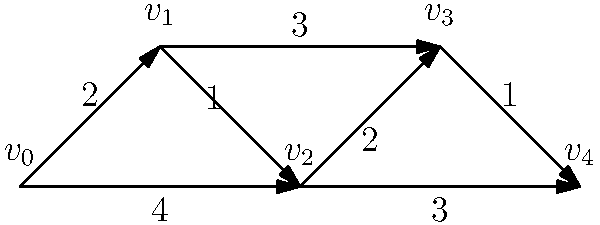A small telecommunication company is expanding its network infrastructure. The graph represents their current network topology, where vertices are data centers and edges are communication links with associated costs. Using Dijkstra's algorithm, what is the shortest path from $v_0$ to $v_4$, and what is its total cost? Let's apply Dijkstra's algorithm step by step:

1) Initialize:
   - Set distance to $v_0$ as 0 and all others as infinity.
   - Set all nodes as unvisited.
   - Set $v_0$ as the current node.

2) For the current node, consider all unvisited neighbors and calculate their tentative distances:
   - $v_1$: 0 + 2 = 2
   - $v_2$: 0 + 4 = 4

3) Mark $v_0$ as visited. Set $v_1$ (lowest tentative distance) as the new current node.

4) From $v_1$:
   - $v_2$: min(4, 2 + 1) = 3
   - $v_3$: 2 + 3 = 5

5) Mark $v_1$ as visited. Set $v_2$ as the new current node.

6) From $v_2$:
   - $v_3$: min(5, 3 + 2) = 5
   - $v_4$: 3 + 3 = 6

7) Mark $v_2$ as visited. Set $v_3$ as the new current node.

8) From $v_3$:
   - $v_4$: min(6, 5 + 1) = 6

9) Mark $v_3$ as visited. Set $v_4$ as the new current node.

10) All nodes visited. Algorithm terminates.

The shortest path is $v_0 \rightarrow v_1 \rightarrow v_2 \rightarrow v_4$ with a total cost of 6.
Answer: $v_0 \rightarrow v_1 \rightarrow v_2 \rightarrow v_4$, cost = 6 